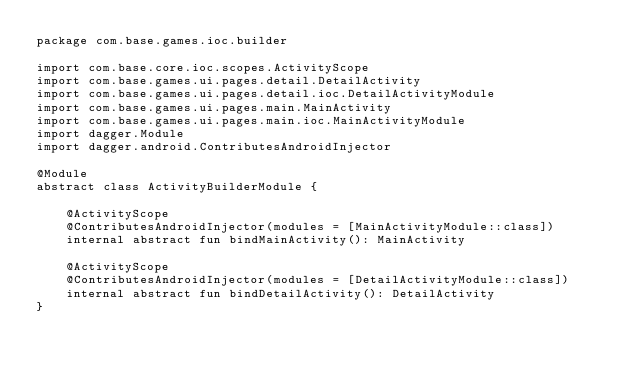Convert code to text. <code><loc_0><loc_0><loc_500><loc_500><_Kotlin_>package com.base.games.ioc.builder

import com.base.core.ioc.scopes.ActivityScope
import com.base.games.ui.pages.detail.DetailActivity
import com.base.games.ui.pages.detail.ioc.DetailActivityModule
import com.base.games.ui.pages.main.MainActivity
import com.base.games.ui.pages.main.ioc.MainActivityModule
import dagger.Module
import dagger.android.ContributesAndroidInjector

@Module
abstract class ActivityBuilderModule {

    @ActivityScope
    @ContributesAndroidInjector(modules = [MainActivityModule::class])
    internal abstract fun bindMainActivity(): MainActivity

    @ActivityScope
    @ContributesAndroidInjector(modules = [DetailActivityModule::class])
    internal abstract fun bindDetailActivity(): DetailActivity
}</code> 